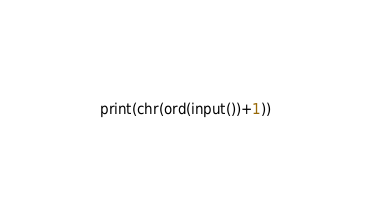Convert code to text. <code><loc_0><loc_0><loc_500><loc_500><_Python_>print(chr(ord(input())+1))</code> 